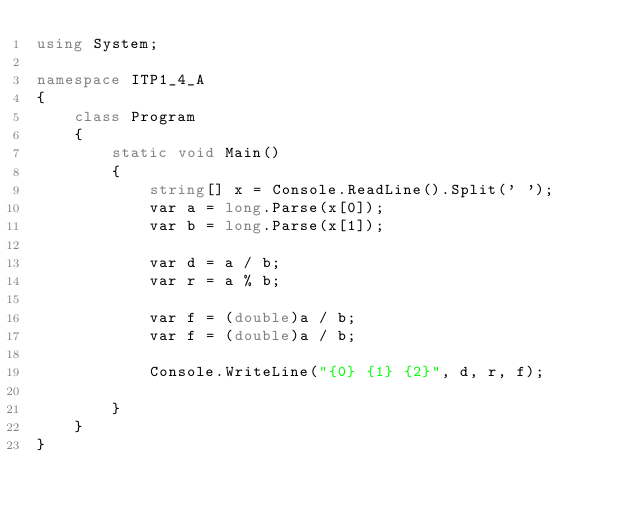Convert code to text. <code><loc_0><loc_0><loc_500><loc_500><_C#_>using System;

namespace ITP1_4_A
{
    class Program
    {
        static void Main()
        {
            string[] x = Console.ReadLine().Split(' ');
            var a = long.Parse(x[0]);
            var b = long.Parse(x[1]);
        
            var d = a / b;
            var r = a % b;
        
            var f = (double)a / b;
            var f = (double)a / b;
        
            Console.WriteLine("{0} {1} {2}", d, r, f);
            
        }
    }
}
</code> 